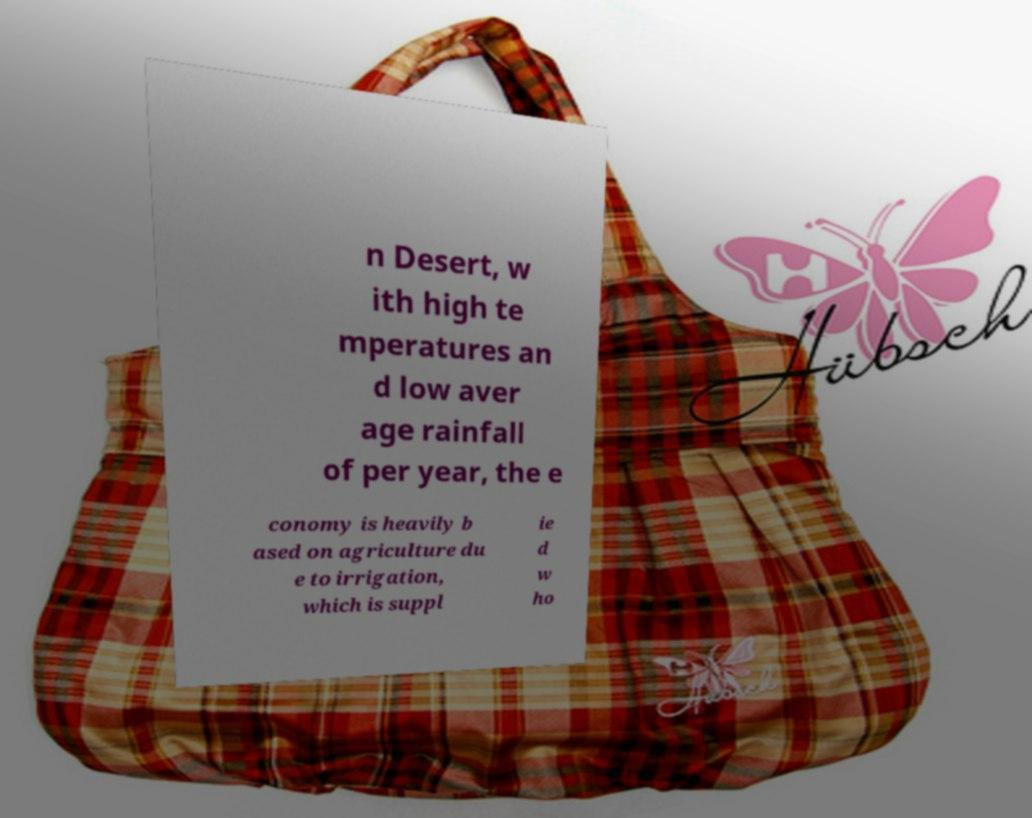Could you extract and type out the text from this image? n Desert, w ith high te mperatures an d low aver age rainfall of per year, the e conomy is heavily b ased on agriculture du e to irrigation, which is suppl ie d w ho 